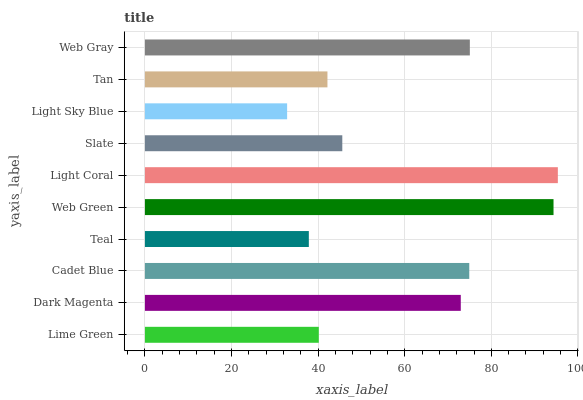Is Light Sky Blue the minimum?
Answer yes or no. Yes. Is Light Coral the maximum?
Answer yes or no. Yes. Is Dark Magenta the minimum?
Answer yes or no. No. Is Dark Magenta the maximum?
Answer yes or no. No. Is Dark Magenta greater than Lime Green?
Answer yes or no. Yes. Is Lime Green less than Dark Magenta?
Answer yes or no. Yes. Is Lime Green greater than Dark Magenta?
Answer yes or no. No. Is Dark Magenta less than Lime Green?
Answer yes or no. No. Is Dark Magenta the high median?
Answer yes or no. Yes. Is Slate the low median?
Answer yes or no. Yes. Is Tan the high median?
Answer yes or no. No. Is Light Sky Blue the low median?
Answer yes or no. No. 